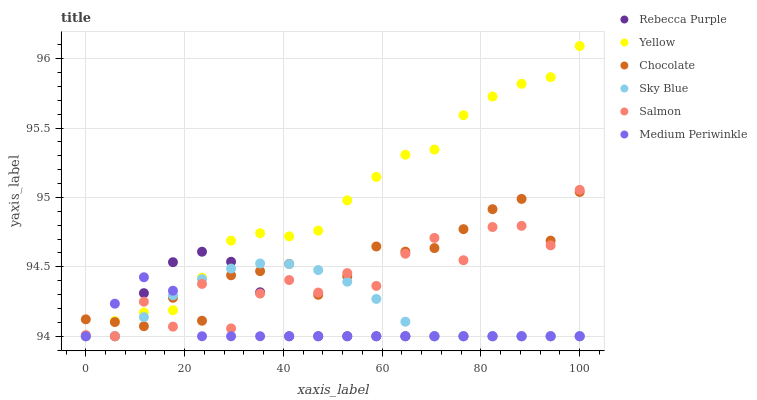Does Medium Periwinkle have the minimum area under the curve?
Answer yes or no. Yes. Does Yellow have the maximum area under the curve?
Answer yes or no. Yes. Does Yellow have the minimum area under the curve?
Answer yes or no. No. Does Medium Periwinkle have the maximum area under the curve?
Answer yes or no. No. Is Sky Blue the smoothest?
Answer yes or no. Yes. Is Salmon the roughest?
Answer yes or no. Yes. Is Medium Periwinkle the smoothest?
Answer yes or no. No. Is Medium Periwinkle the roughest?
Answer yes or no. No. Does Salmon have the lowest value?
Answer yes or no. Yes. Does Chocolate have the lowest value?
Answer yes or no. No. Does Yellow have the highest value?
Answer yes or no. Yes. Does Medium Periwinkle have the highest value?
Answer yes or no. No. Does Yellow intersect Medium Periwinkle?
Answer yes or no. Yes. Is Yellow less than Medium Periwinkle?
Answer yes or no. No. Is Yellow greater than Medium Periwinkle?
Answer yes or no. No. 